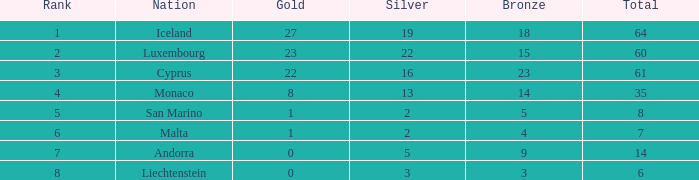In the under 19 category, what position does iceland hold for silver medals? None. 